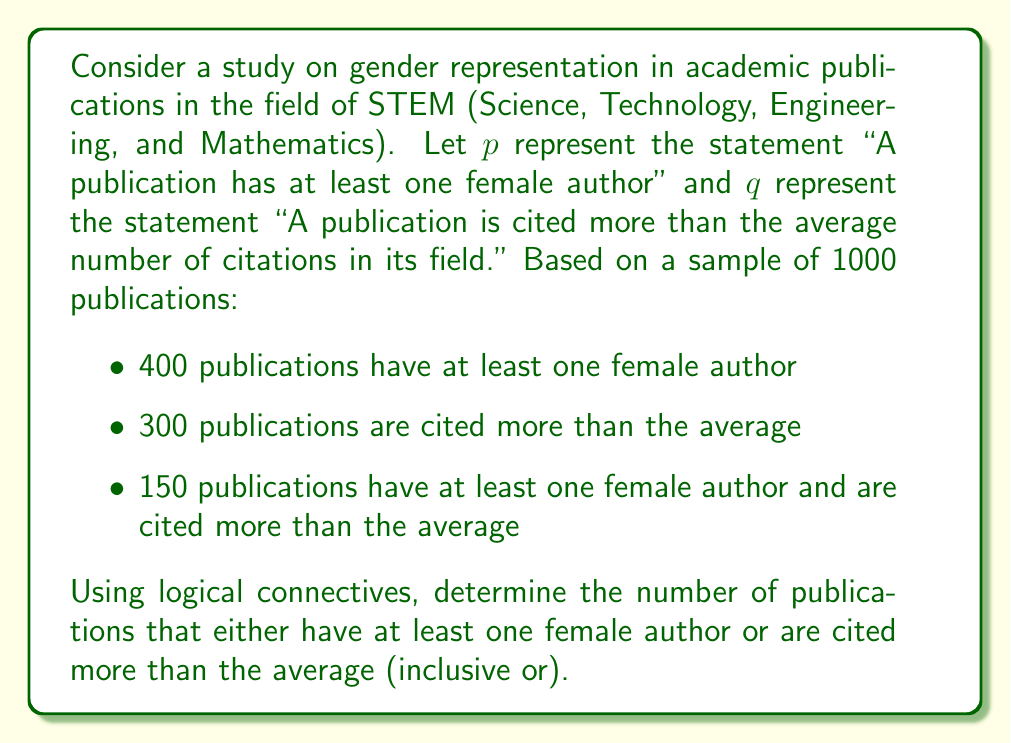Teach me how to tackle this problem. Let's approach this step-by-step using logical connectives and set theory:

1) We need to find $p \lor q$ (inclusive or), which means publications that satisfy either $p$ or $q$ or both.

2) In set theory, this is equivalent to the union of sets $P$ and $Q$, where:
   $P$ = set of publications with at least one female author
   $Q$ = set of publications cited more than average

3) The formula for the number of elements in the union of two sets is:
   $|P \cup Q| = |P| + |Q| - |P \cap Q|$

   Where $|P \cap Q|$ represents the intersection of sets $P$ and $Q$

4) From the given information:
   $|P| = 400$ (publications with at least one female author)
   $|Q| = 300$ (publications cited more than average)
   $|P \cap Q| = 150$ (publications satisfying both conditions)

5) Substituting these values into the formula:
   $|P \cup Q| = 400 + 300 - 150 = 550$

Therefore, 550 publications either have at least one female author or are cited more than the average.

This analysis helps highlight the representation of women in academic publications and the potential correlation with citation rates, which is crucial information for advocating gender equality in academia.
Answer: 550 publications 